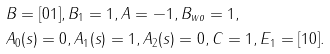<formula> <loc_0><loc_0><loc_500><loc_500>& B = [ 0 1 ] , B _ { 1 } = 1 , A = - 1 , B _ { w o } = 1 , \\ & A _ { 0 } ( s ) = 0 , A _ { 1 } ( s ) = 1 , A _ { 2 } ( s ) = 0 , C = 1 , E _ { 1 } = [ 1 0 ] .</formula> 